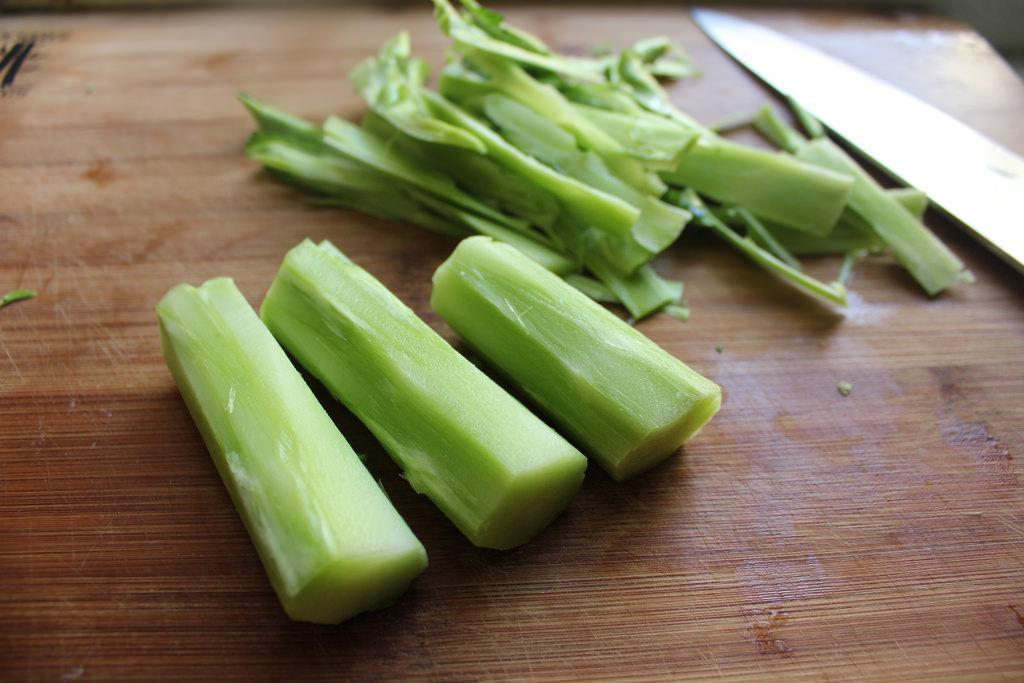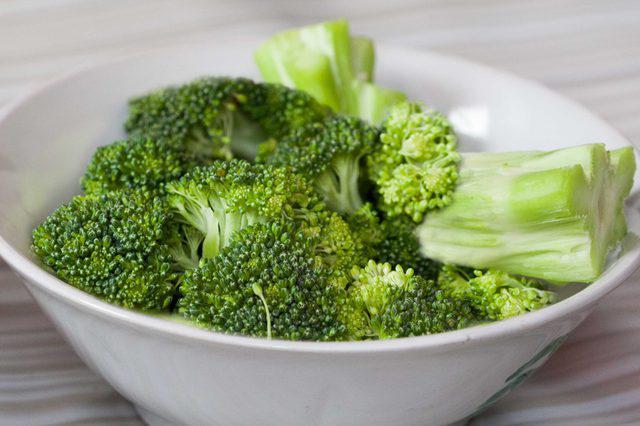The first image is the image on the left, the second image is the image on the right. For the images displayed, is the sentence "An image includes a white bowl that contains multiple broccoli florets." factually correct? Answer yes or no. Yes. The first image is the image on the left, the second image is the image on the right. Examine the images to the left and right. Is the description "Brocolli sits in a white bowl in the image on the right." accurate? Answer yes or no. Yes. The first image is the image on the left, the second image is the image on the right. For the images shown, is this caption "The broccoli in the image on the right is in a white bowl." true? Answer yes or no. Yes. The first image is the image on the left, the second image is the image on the right. Examine the images to the left and right. Is the description "An image shows a white bowl that contains some broccoli stalks." accurate? Answer yes or no. Yes. 